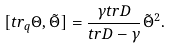<formula> <loc_0><loc_0><loc_500><loc_500>[ t r _ { q } \Theta , \tilde { \Theta } ] = \frac { \gamma t r D } { t r D - \gamma } \tilde { \Theta } ^ { 2 } .</formula> 